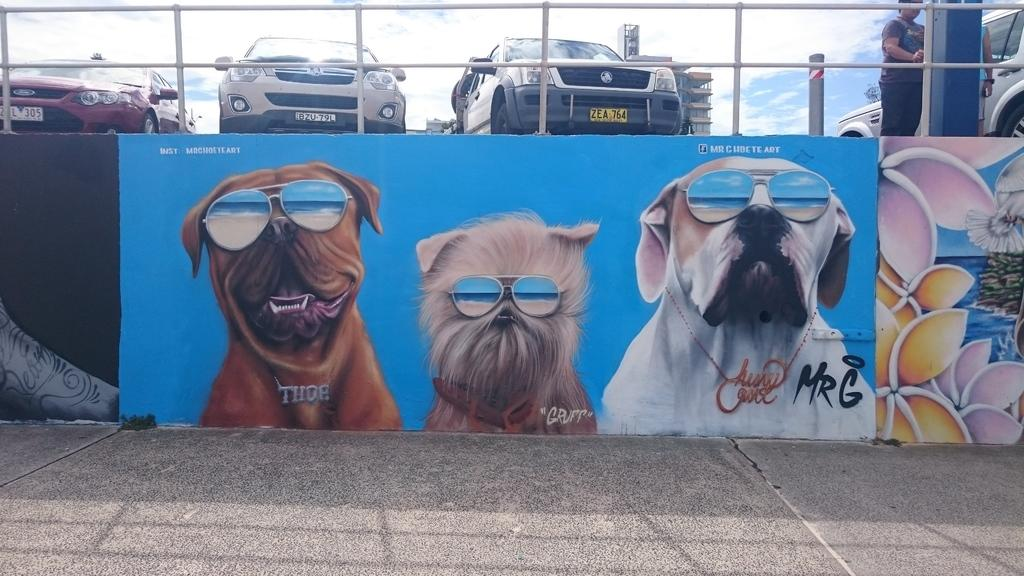What type of artwork is displayed on the wall in the image? There are dog and flower paintings on the wall. What can be seen in the foreground of the image? There is a metal fence in the image. Are there any people present in the image? Yes, there are people standing in the image. What type of structures are visible in the background? There are buildings visible in the image. How would you describe the weather based on the sky in the image? The sky is blue and cloudy, suggesting a partly cloudy day. What type of cheese is being taught by the people in the image? There is no cheese or teaching activity present in the image. How does the sleet affect the metal fence in the image? There is no sleet present in the image; the sky is blue and cloudy, indicating a partly cloudy day. 